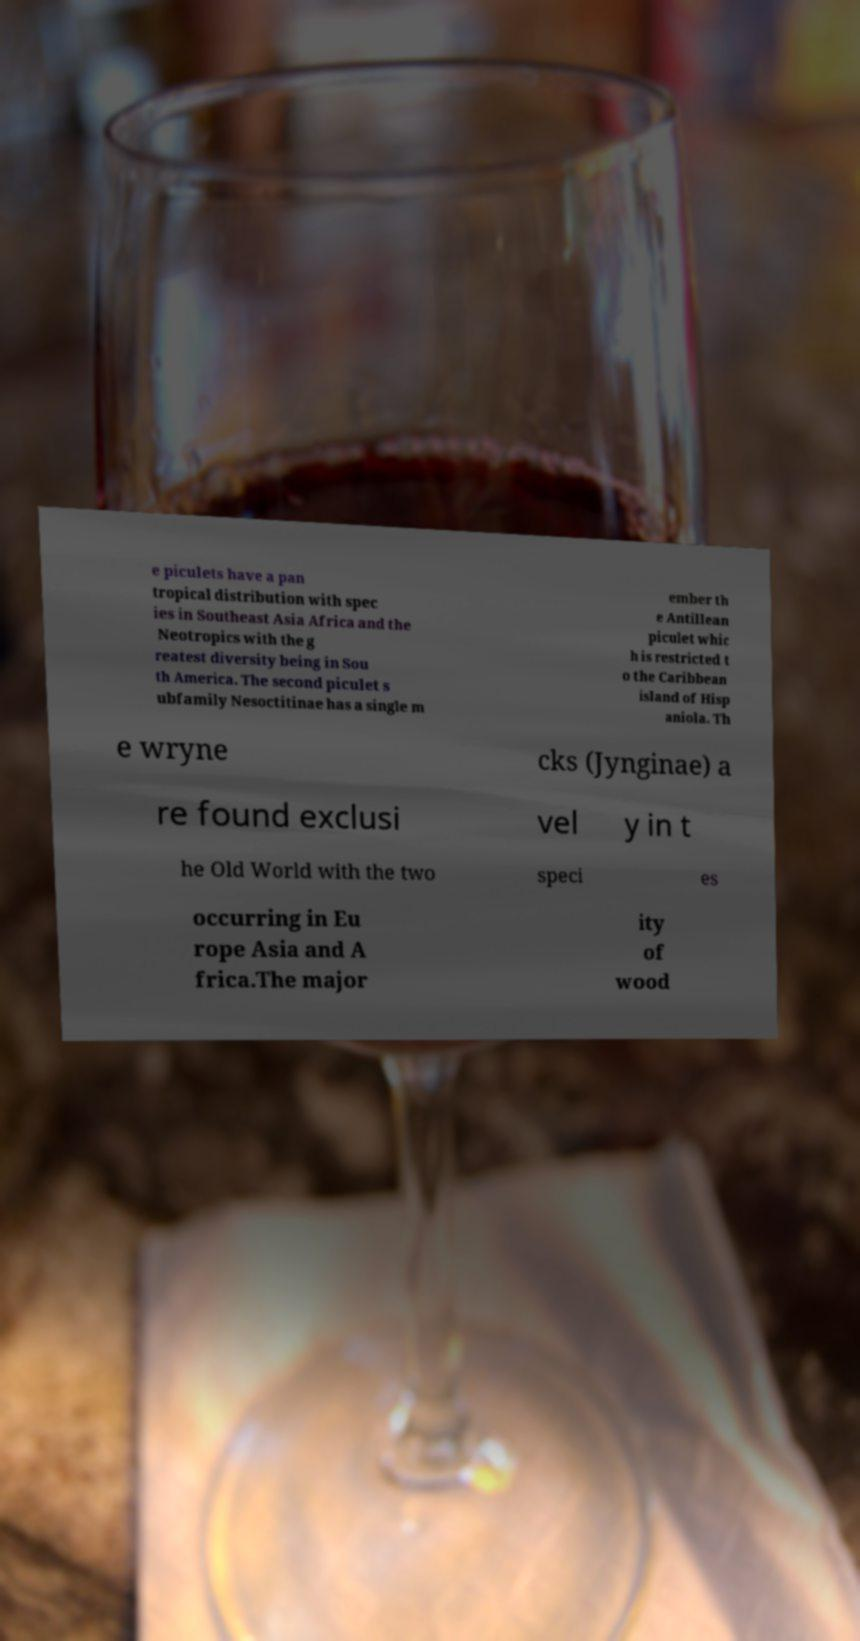Can you read and provide the text displayed in the image?This photo seems to have some interesting text. Can you extract and type it out for me? e piculets have a pan tropical distribution with spec ies in Southeast Asia Africa and the Neotropics with the g reatest diversity being in Sou th America. The second piculet s ubfamily Nesoctitinae has a single m ember th e Antillean piculet whic h is restricted t o the Caribbean island of Hisp aniola. Th e wryne cks (Jynginae) a re found exclusi vel y in t he Old World with the two speci es occurring in Eu rope Asia and A frica.The major ity of wood 